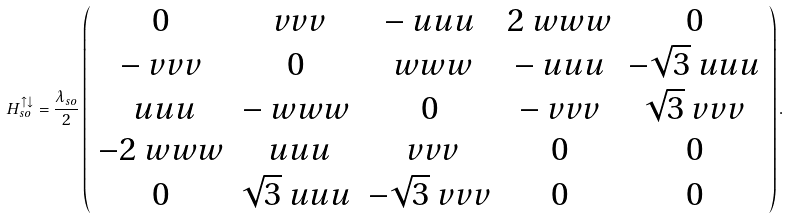Convert formula to latex. <formula><loc_0><loc_0><loc_500><loc_500>H _ { s o } ^ { \uparrow \downarrow } = \frac { \lambda _ { s o } } { 2 } \left ( \begin{array} { c c c c c } 0 & \ v v v & - \ u u u & 2 \ w w w & 0 \\ - \ v v v & 0 & \ w w w & - \ u u u & - \sqrt { 3 } \ u u u \\ \ u u u & - \ w w w & 0 & - \ v v v & \sqrt { 3 } \ v v v \\ - 2 \ w w w & \ u u u & \ v v v & 0 & 0 \\ 0 & \sqrt { 3 } \ u u u & - \sqrt { 3 } \ v v v & 0 & 0 \end{array} \right ) .</formula> 